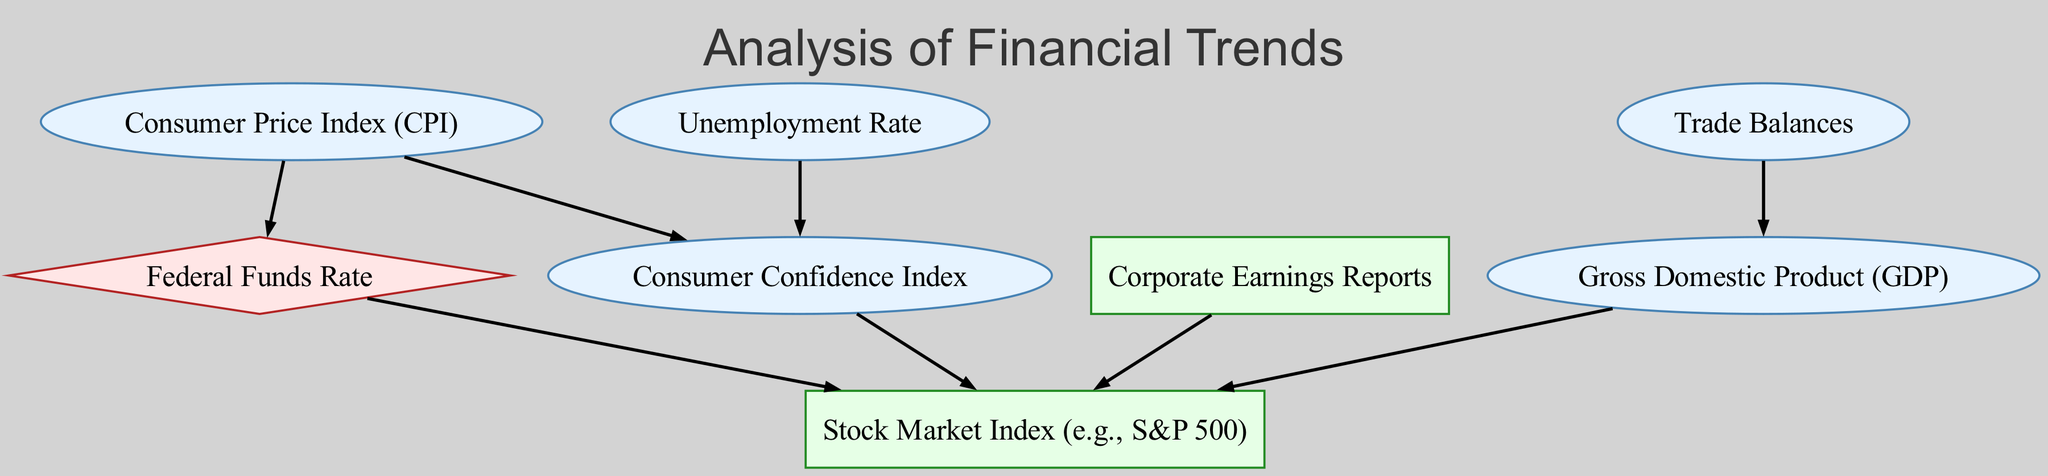What are the economic indicators depicted in the diagram? The diagram includes several economic indicators: Gross Domestic Product, Consumer Price Index, Unemployment Rate, Consumer Confidence Index, and Trade Balances. These nodes are labeled as economic indicators of the economy's health.
Answer: Gross Domestic Product, Consumer Price Index, Unemployment Rate, Consumer Confidence Index, Trade Balances How many nodes are there in the diagram? The total number of nodes can be determined by counting all unique elements included in the diagram. The provided data lists eight elements, each representing a node in the graph.
Answer: Eight What is the relationship between the Consumer Price Index and the Federal Funds Rate? The diagram shows a directed edge from Consumer Price Index to Federal Funds Rate, indicating that changes in the Consumer Price Index influence the Federal Funds Rate.
Answer: Influence How many financial indicators are present in the directed graph? The graph specifies two financial indicators: Stock Market Index and Corporate Earnings Reports. By counting them, we find there are two financial indicators in total.
Answer: Two Which economic indicator influences the Stock Market Index the most based on the diagram? The Stock Market Index is influenced by multiple indicators such as GDP, Federal Funds Rate, Corporate Earnings, and Consumer Confidence Index; however, GDP is a primary economic indicator and thus plays a significant role in influencing the Stock Market Index.
Answer: GDP What type of node is the Federal Funds Rate? The Federal Funds Rate is classified as a monetary policy node, indicated by its shape and color coding in the diagram.
Answer: Monetary policy How does the Unemployment Rate affect the Consumer Confidence Index? The Unemployment Rate has a direct influence on the Consumer Confidence Index, as indicated by a directed edge from the Unemployment Rate to the Consumer Confidence Index in the diagram, signifying that changes in the unemployment rate impact consumer sentiment and confidence.
Answer: Signals economic health Which node has the most incoming edges? The Stock Market Index receives edges from GDP, Federal Funds Rate, Corporate Earnings, and Consumer Confidence Index, making it the node with the most incoming edges, reflecting multiple influences.
Answer: Stock Market Index What indicates the relationship between Trade Balances and GDP? The graph shows a directed edge from Trade Balances to GDP, indicating that Trade Balances impact the Gross Domestic Product of a country, which contributes to the overall economic health.
Answer: Impact 